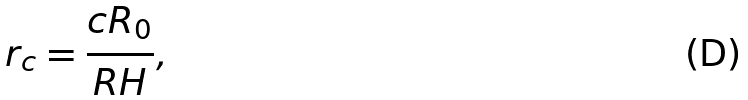<formula> <loc_0><loc_0><loc_500><loc_500>r _ { c } = \frac { c R _ { 0 } } { R H } ,</formula> 